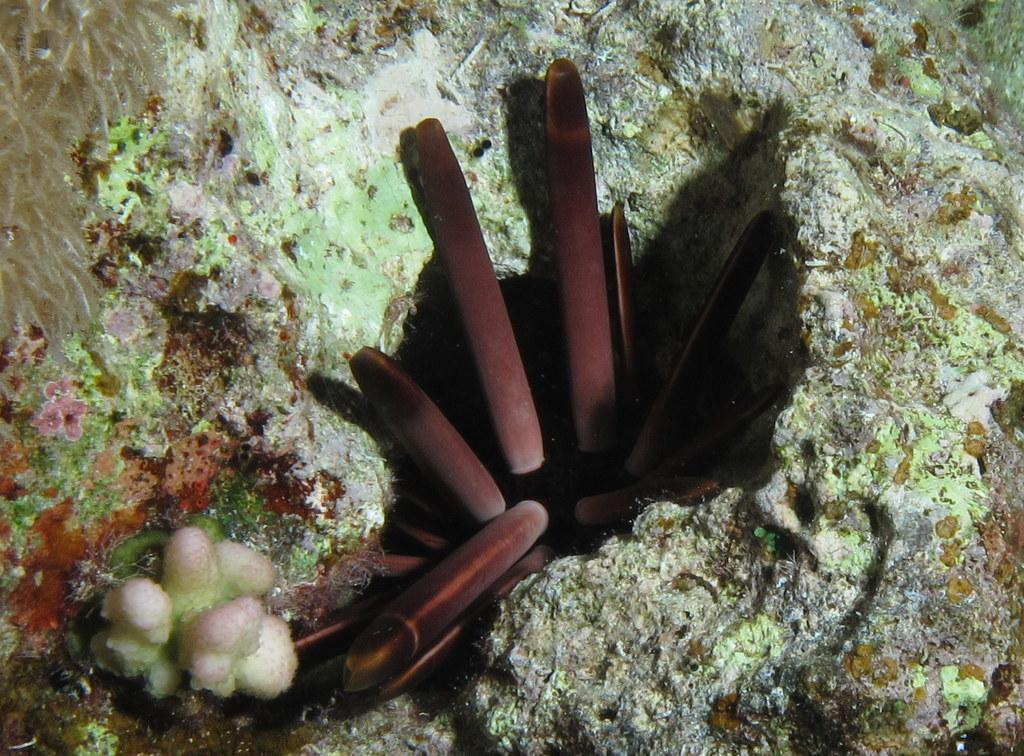What color are the objects in the image? The objects in the image have a brown color. What type of plants can be seen in the image? Aquatic plants are visible in the image. Can you describe the setting of the image? The image is an underwater scene. How many bones are visible in the image? There are no bones visible in the image; it is an underwater scene with aquatic plants. 